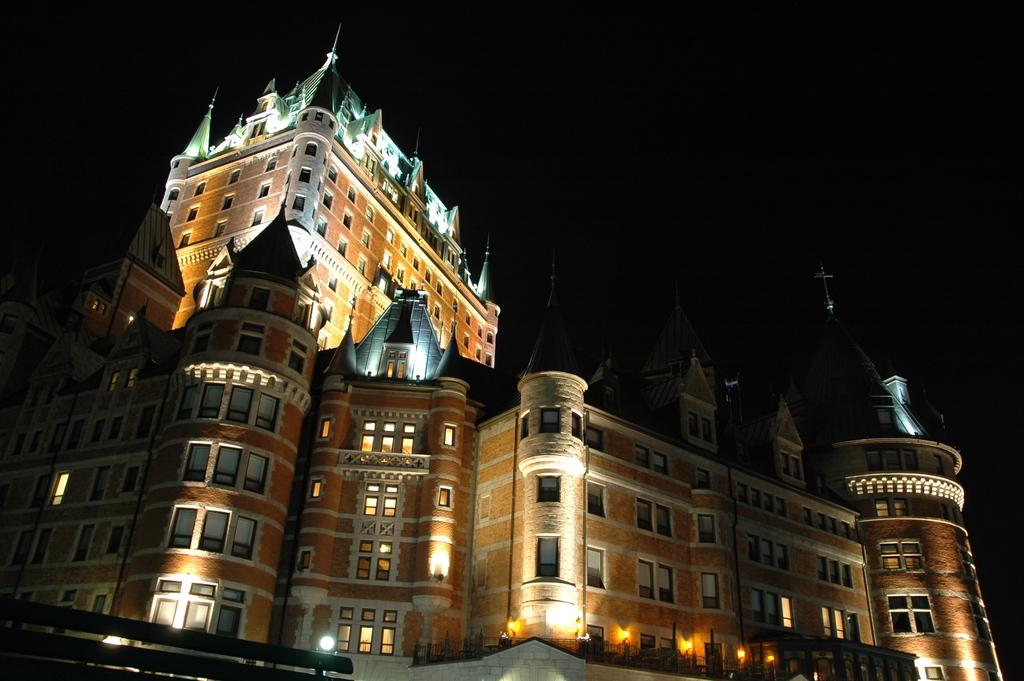What is the main structure in the image? There is a castle in the image. What feature of the castle is mentioned in the facts? The castle has lights. Where is the fence located in the image? The fence is in the left bottom of the image. What is the color of the background in the image? The background of the image is black in color. What type of design is being taught at the school in the image? There is no school present in the image, so it is not possible to determine what type of design is being taught. Can you see a hill in the background of the image? The background of the image is black, so it is not possible to see a hill or any other landscape features. 